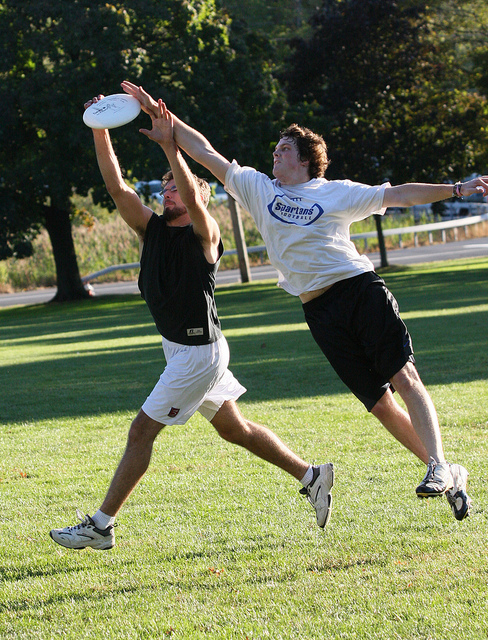Identify the text displayed in this image. Saartans 